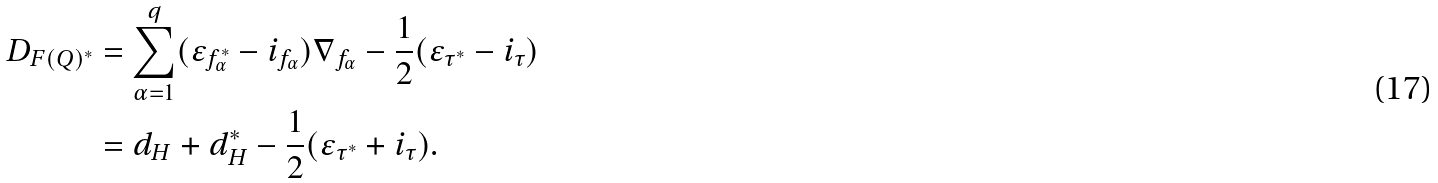Convert formula to latex. <formula><loc_0><loc_0><loc_500><loc_500>D _ { F ( Q ) ^ { * } } & = \sum _ { \alpha = 1 } ^ { q } ( \varepsilon _ { f ^ { * } _ { \alpha } } - i _ { f _ { \alpha } } ) \nabla _ { f _ { \alpha } } - \frac { 1 } { 2 } ( \varepsilon _ { \tau ^ { * } } - i _ { \tau } ) \\ & = d _ { H } + d ^ { * } _ { H } - \frac { 1 } { 2 } ( \varepsilon _ { \tau ^ { * } } + i _ { \tau } ) .</formula> 